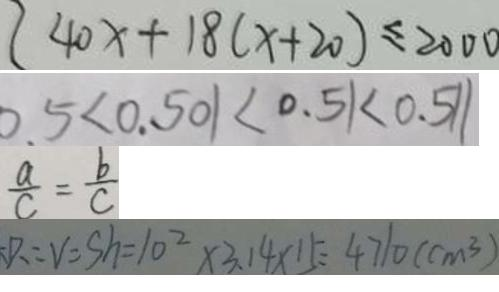<formula> <loc_0><loc_0><loc_500><loc_500>4 0 x + 1 8 ( x + 2 0 ) \leq 2 0 0 0 
 0 . 5 < 0 . 5 0 1 < 0 . 5 1 < 0 . 5 1 1 
 \frac { a } { c } = \frac { b } { c } 
 P = V = S h = 1 0 ^ { 2 } \times 3 . 1 4 \times 1 5 = 4 7 1 0 ( c m ^ { 3 } )</formula> 